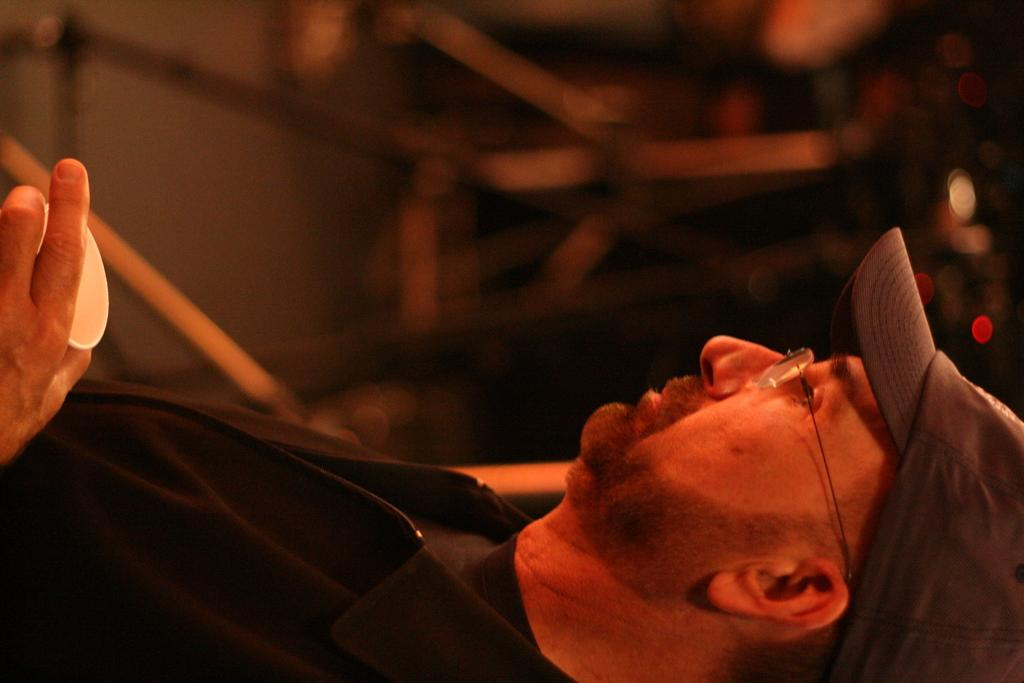What can be seen in the image? There is a person in the image. Can you describe the person's clothing? The person is wearing a black jacket, spectacles, and a cap. What is the person holding in their hand? The person is holding a cup in their hand. How would you describe the background of the image? The background of the image is dark and slightly blurred. What type of sticks can be seen in the person's hand in the image? There are no sticks visible in the person's hand in the image. What attraction is the person visiting in the image? There is no attraction mentioned or visible in the image. 